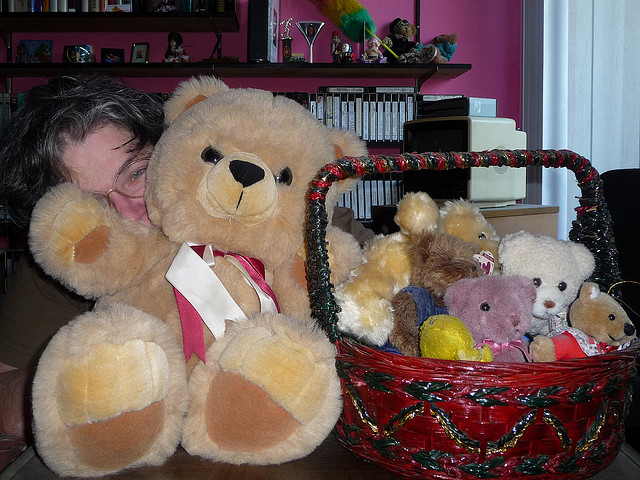<image>Is this teddy bear for sale? It is not known if the teddy bear is for sale. Is this teddy bear for sale? I don't know if this teddy bear is for sale. It seems that it is not available for purchase. 